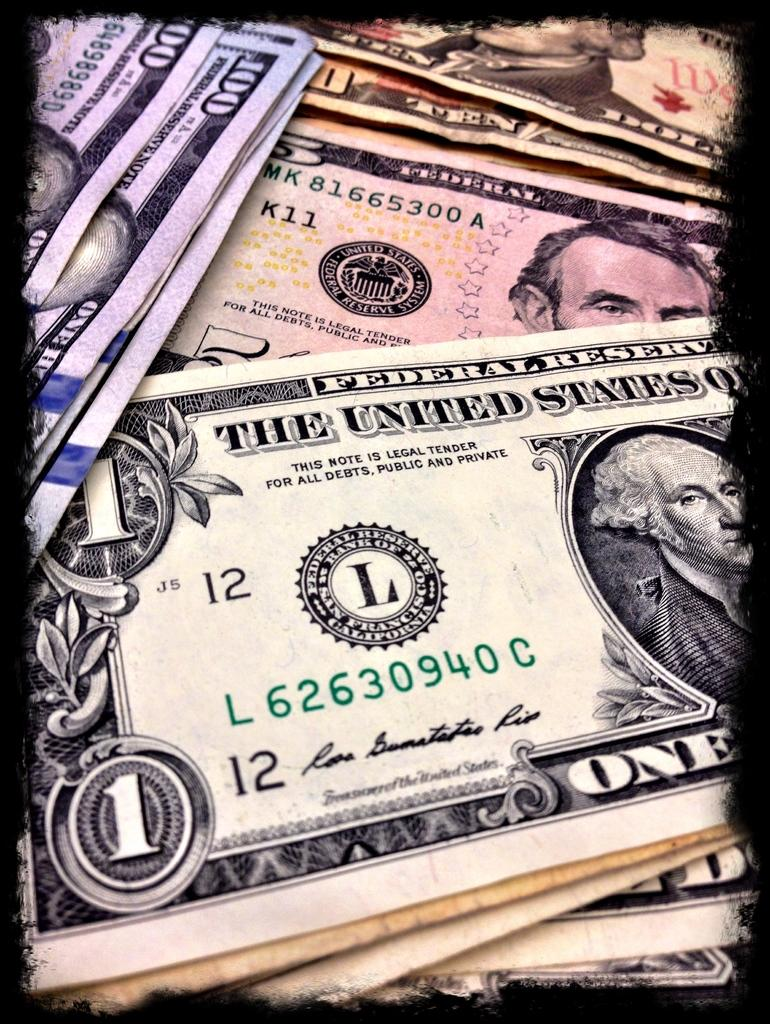What type of items can be seen in the image? There are currency notes in the image. Can you describe the appearance of the currency notes? The currency notes have distinct designs and denominations. What might be the purpose of having currency notes in the image? The currency notes might be used for transactions or as a representation of wealth. What type of tent can be seen in the image? There is no tent present in the image; it only contains currency notes. 